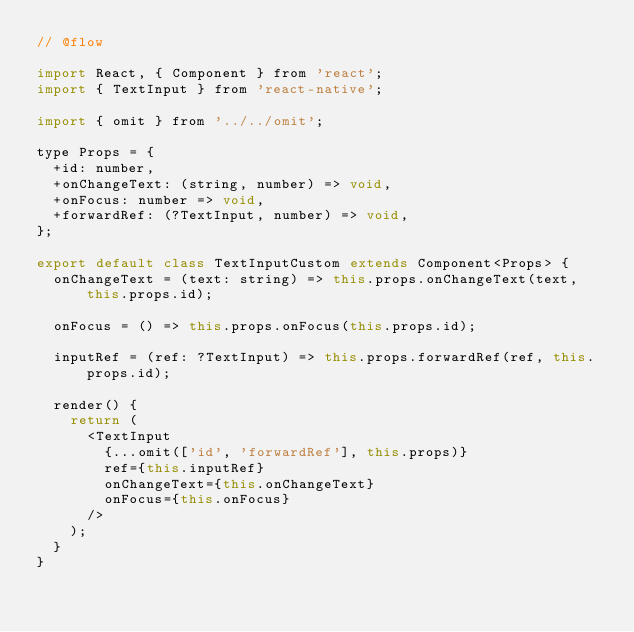Convert code to text. <code><loc_0><loc_0><loc_500><loc_500><_JavaScript_>// @flow

import React, { Component } from 'react';
import { TextInput } from 'react-native';

import { omit } from '../../omit';

type Props = {
  +id: number,
  +onChangeText: (string, number) => void,
  +onFocus: number => void,
  +forwardRef: (?TextInput, number) => void,
};

export default class TextInputCustom extends Component<Props> {
  onChangeText = (text: string) => this.props.onChangeText(text, this.props.id);

  onFocus = () => this.props.onFocus(this.props.id);

  inputRef = (ref: ?TextInput) => this.props.forwardRef(ref, this.props.id);

  render() {
    return (
      <TextInput
        {...omit(['id', 'forwardRef'], this.props)}
        ref={this.inputRef}
        onChangeText={this.onChangeText}
        onFocus={this.onFocus}
      />
    );
  }
}
</code> 